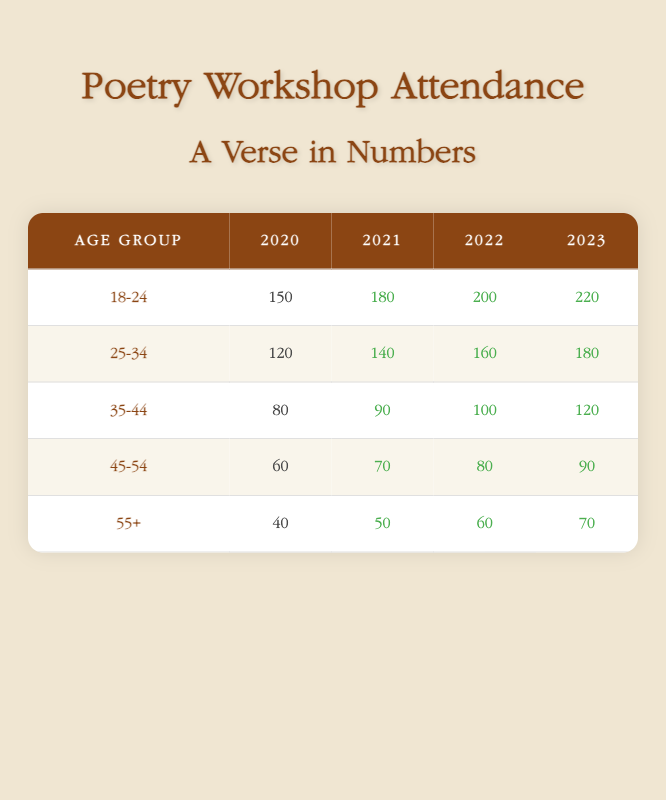What was the highest attendance for the age group 18-24? Looking at the table for the age group 18-24, the attendances over the years are: 150 (2020), 180 (2021), 200 (2022), and 220 (2023). The maximum of these values is 220 in 2023.
Answer: 220 Which age group had the lowest attendance in 2020? In 2020, the attendances were: 150 (18-24), 120 (25-34), 80 (35-44), 60 (45-54), and 40 (55+). The age group with the lowest attendance is 55+.
Answer: 40 What is the total attendance for the age group 35-44 across all years? Summing the attendances for the age group 35-44: 80 (2020) + 90 (2021) + 100 (2022) + 120 (2023) gives a total of 390.
Answer: 390 Did attendance for the age group 45-54 increase every year from 2020 to 2023? Examining the attendances for the age group 45-54: 60 (2020), 70 (2021), 80 (2022), and 90 (2023), we see that each value is greater than the previous one, indicating a consistent increase.
Answer: Yes What was the average attendance of the age group 25-34 over the four years? For the age group 25-34, attendances are: 120 (2020), 140 (2021), 160 (2022), and 180 (2023). The sum is 120 + 140 + 160 + 180 = 600. There are 4 years, so the average is 600 / 4 = 150.
Answer: 150 Which year had the highest total attendance across all age groups? Calculating the total attendance for each year: 2020 = 150 + 120 + 80 + 60 + 40 = 450; 2021 = 180 + 140 + 90 + 70 + 50 = 530; 2022 = 200 + 160 + 100 + 80 + 60 = 600; 2023 = 220 + 180 + 120 + 90 + 70 = 680. The highest total is in 2023 with 680.
Answer: 680 Is the attendance for the age group 55+ higher in 2022 than in 2021? Attendance for 55+ was 50 in 2021 and 60 in 2022. Since 60 is greater than 50, the attendance did increase from 2021 to 2022.
Answer: Yes Between 2020 and 2023, which age group saw the largest percentage increase in attendance? Calculating percentage increases for each age group from 2020 to 2023: 18-24: ((220-150)/150)*100 = 46.67%; 25-34: ((180-120)/120)*100 = 50%; 35-44: ((120-80)/80)*100 = 50%; 45-54: ((90-60)/60)*100 = 50%; 55+: ((70-40)/40)*100 = 75%. The largest percentage increase is for the age group 55+.
Answer: 75% 